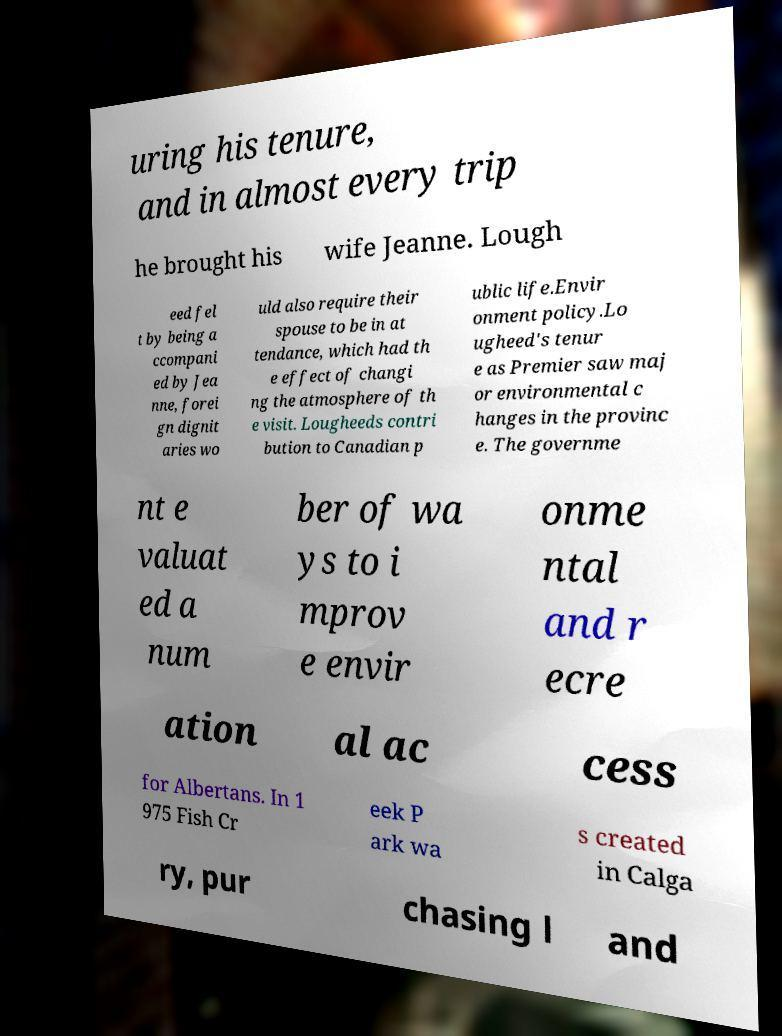What messages or text are displayed in this image? I need them in a readable, typed format. uring his tenure, and in almost every trip he brought his wife Jeanne. Lough eed fel t by being a ccompani ed by Jea nne, forei gn dignit aries wo uld also require their spouse to be in at tendance, which had th e effect of changi ng the atmosphere of th e visit. Lougheeds contri bution to Canadian p ublic life.Envir onment policy.Lo ugheed's tenur e as Premier saw maj or environmental c hanges in the provinc e. The governme nt e valuat ed a num ber of wa ys to i mprov e envir onme ntal and r ecre ation al ac cess for Albertans. In 1 975 Fish Cr eek P ark wa s created in Calga ry, pur chasing l and 